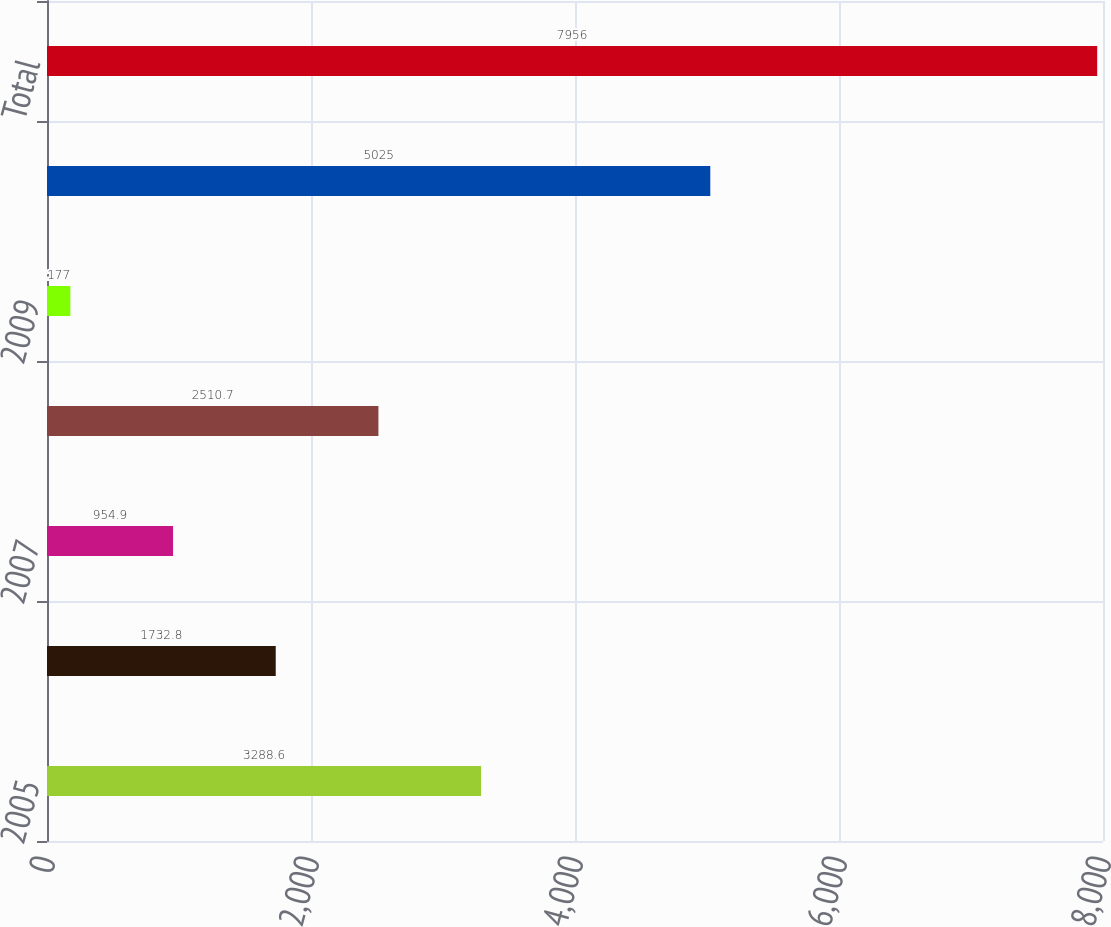Convert chart. <chart><loc_0><loc_0><loc_500><loc_500><bar_chart><fcel>2005<fcel>2006<fcel>2007<fcel>2008<fcel>2009<fcel>2010 and thereafter<fcel>Total<nl><fcel>3288.6<fcel>1732.8<fcel>954.9<fcel>2510.7<fcel>177<fcel>5025<fcel>7956<nl></chart> 